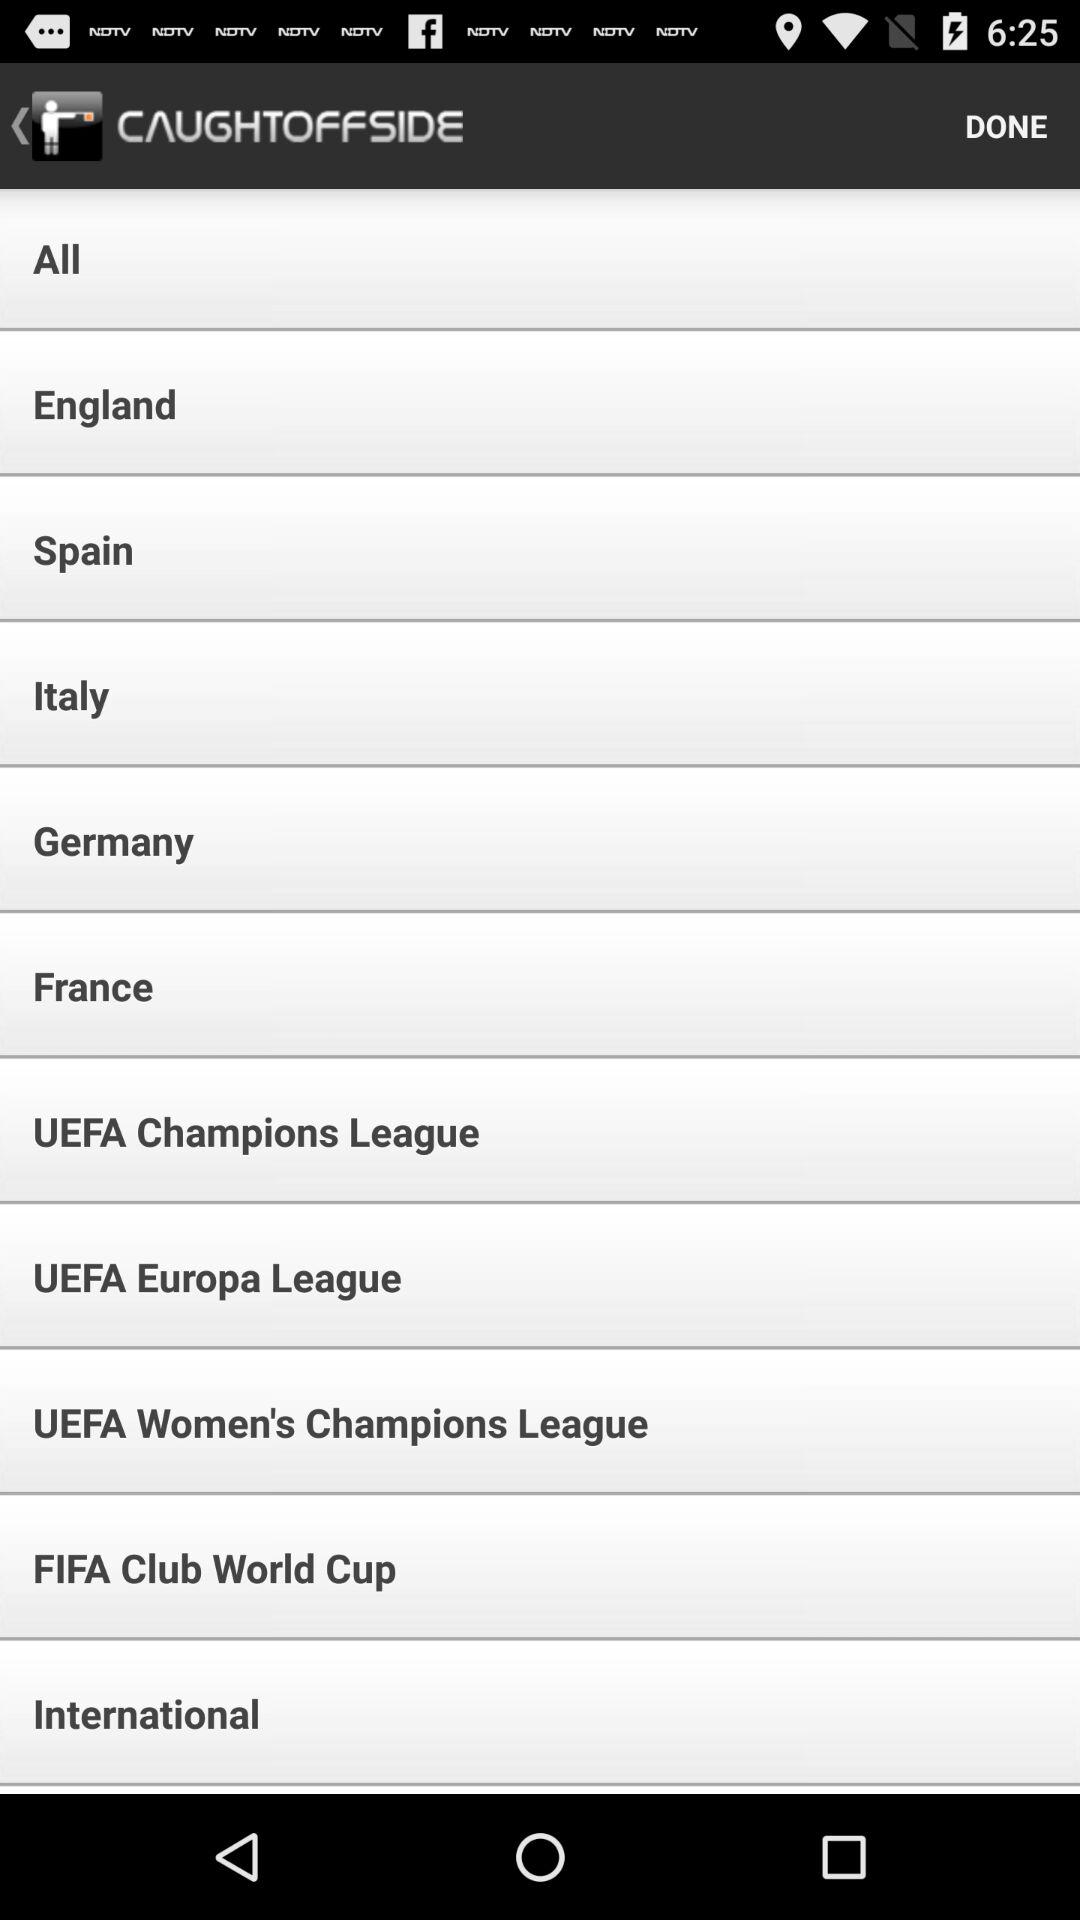What is the name of the application? The name of the application is "CAUGHTOFFSIDE". 